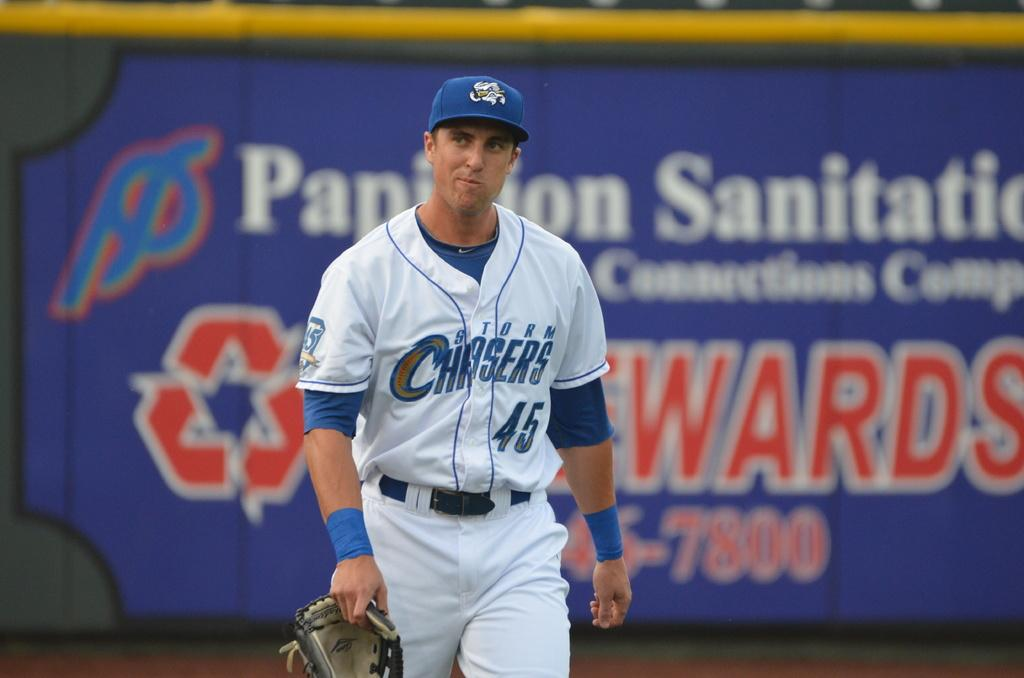<image>
Describe the image concisely. A baseball player for the Storm Chasers walks across the field. 